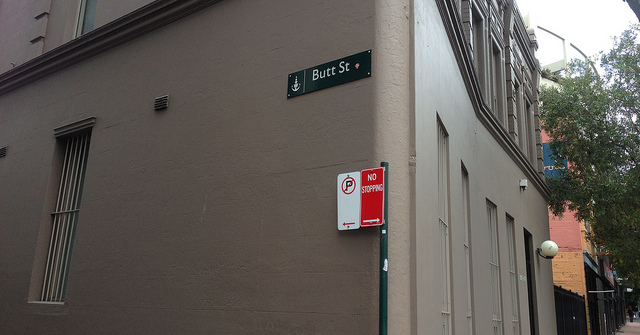Please identify all text content in this image. Butt St NO STOPPING 